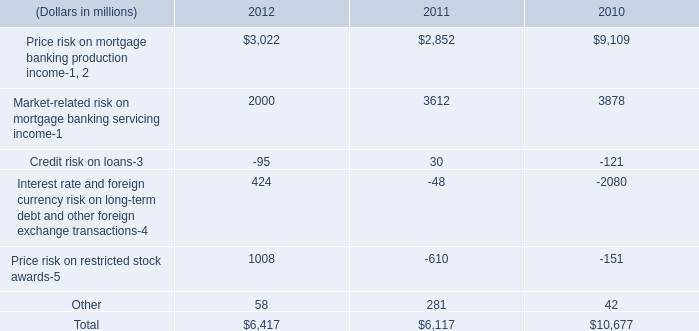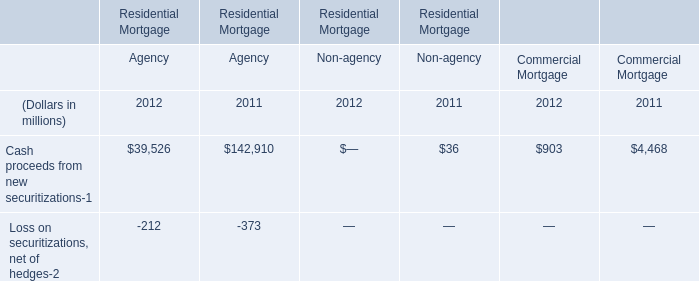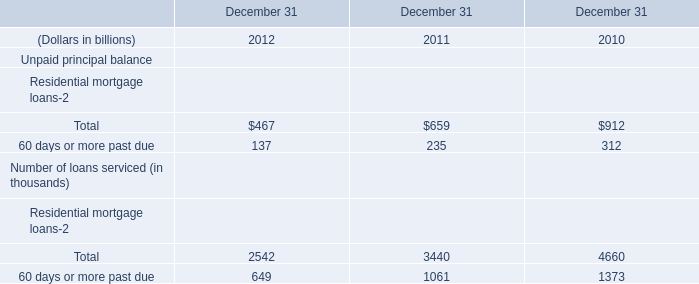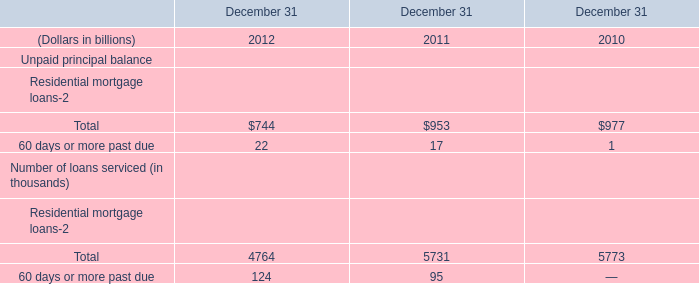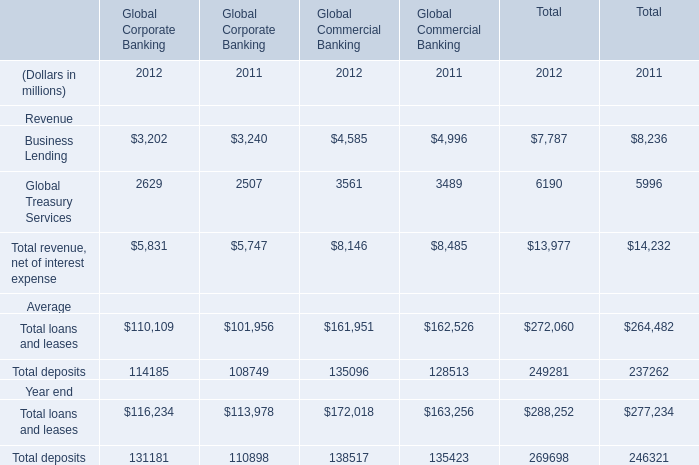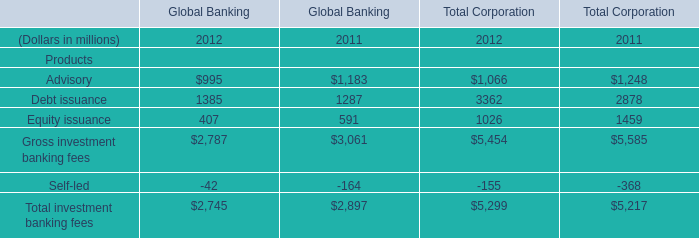In terms of Global Banking,what is the ratio of Debt issuance to the total Gross investment banking fees in 2012? 
Computations: (1385 / 2787)
Answer: 0.49695. 